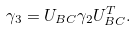Convert formula to latex. <formula><loc_0><loc_0><loc_500><loc_500>\gamma _ { 3 } = U _ { B C } \gamma _ { 2 } U _ { B C } ^ { T } .</formula> 